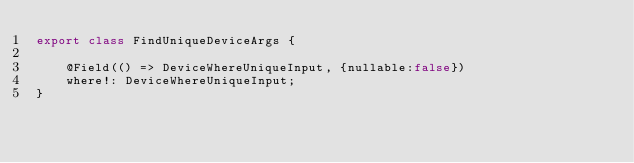<code> <loc_0><loc_0><loc_500><loc_500><_TypeScript_>export class FindUniqueDeviceArgs {

    @Field(() => DeviceWhereUniqueInput, {nullable:false})
    where!: DeviceWhereUniqueInput;
}
</code> 